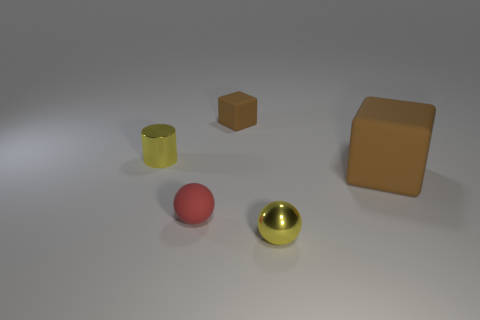There is a tiny rubber thing that is right of the small rubber object in front of the small yellow metallic cylinder; are there any tiny metal things left of it?
Provide a succinct answer. Yes. Are any large purple spheres visible?
Keep it short and to the point. No. Is the number of balls in front of the red matte thing greater than the number of metallic balls that are behind the small yellow metal cylinder?
Your answer should be very brief. Yes. What is the size of the thing that is the same material as the yellow sphere?
Offer a terse response. Small. There is a brown thing on the right side of the brown thing that is behind the cube that is in front of the shiny cylinder; what is its size?
Your response must be concise. Large. There is a rubber cube that is right of the shiny ball; what color is it?
Keep it short and to the point. Brown. Is the number of small yellow spheres that are to the left of the small brown block greater than the number of large gray metal blocks?
Make the answer very short. No. Is the shape of the tiny yellow object that is behind the tiny red rubber sphere the same as  the tiny brown matte thing?
Your response must be concise. No. How many red objects are either shiny cylinders or tiny shiny things?
Your answer should be very brief. 0. Is the number of tiny red balls greater than the number of rubber blocks?
Provide a succinct answer. No. 